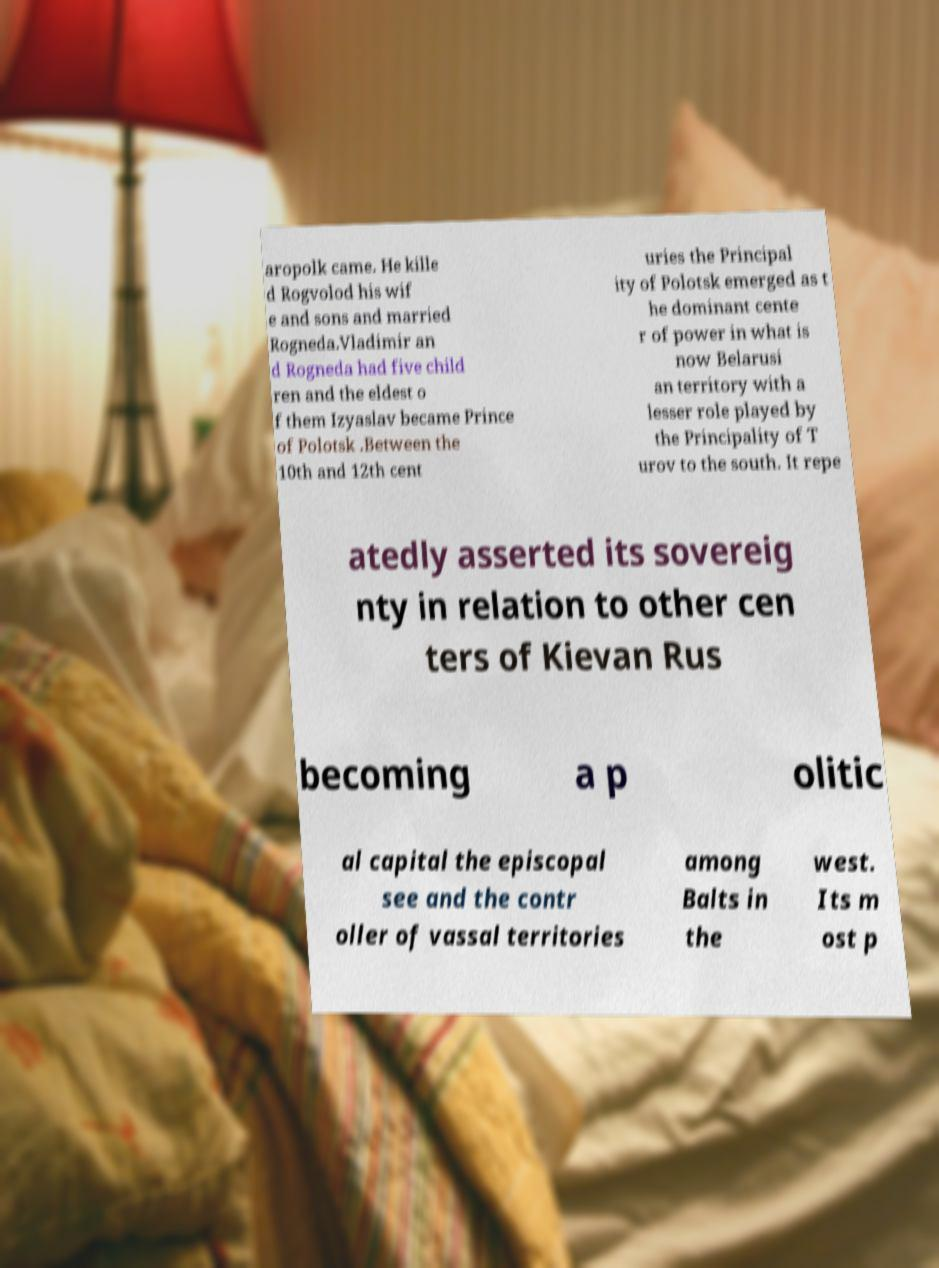Could you extract and type out the text from this image? aropolk came. He kille d Rogvolod his wif e and sons and married Rogneda.Vladimir an d Rogneda had five child ren and the eldest o f them Izyaslav became Prince of Polotsk .Between the 10th and 12th cent uries the Principal ity of Polotsk emerged as t he dominant cente r of power in what is now Belarusi an territory with a lesser role played by the Principality of T urov to the south. It repe atedly asserted its sovereig nty in relation to other cen ters of Kievan Rus becoming a p olitic al capital the episcopal see and the contr oller of vassal territories among Balts in the west. Its m ost p 